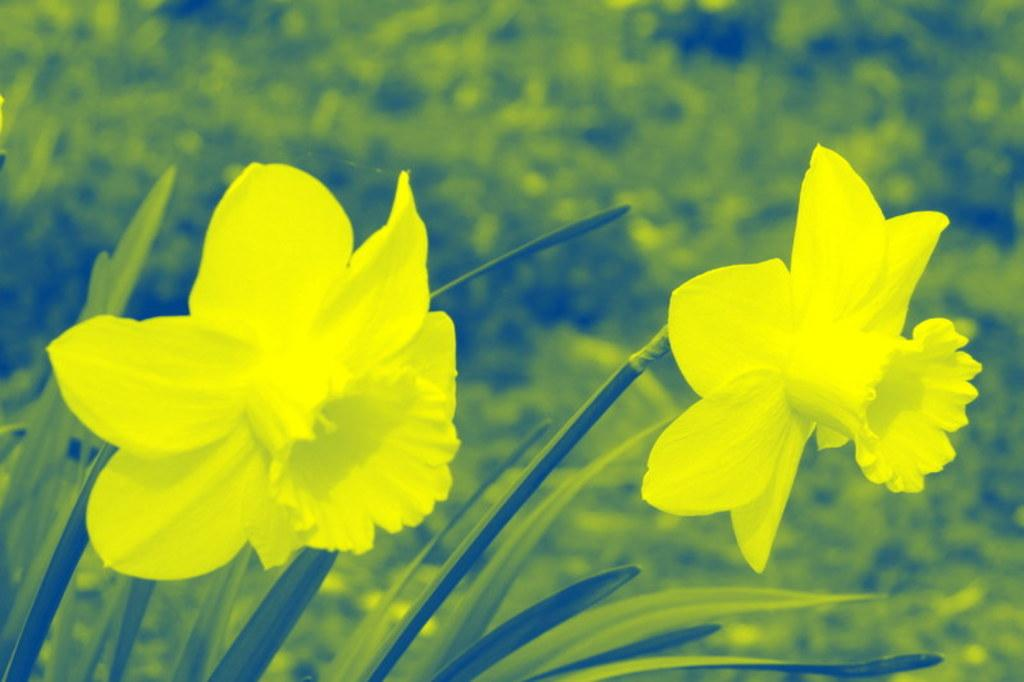What type of plants can be seen in the image? There are plants with flowers in the image. How would you describe the background of the image? The background of the image is blurred. Can you identify any other plants in the image besides the ones with flowers? Yes, plants are visible in the background of the image. How many tickets are needed to ride the moon in the image? There is no moon or any indication of a ride in the image. 